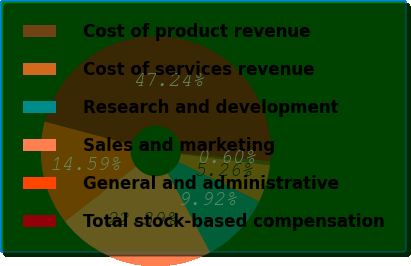<chart> <loc_0><loc_0><loc_500><loc_500><pie_chart><fcel>Cost of product revenue<fcel>Cost of services revenue<fcel>Research and development<fcel>Sales and marketing<fcel>General and administrative<fcel>Total stock-based compensation<nl><fcel>0.6%<fcel>5.26%<fcel>9.92%<fcel>22.39%<fcel>14.59%<fcel>47.24%<nl></chart> 